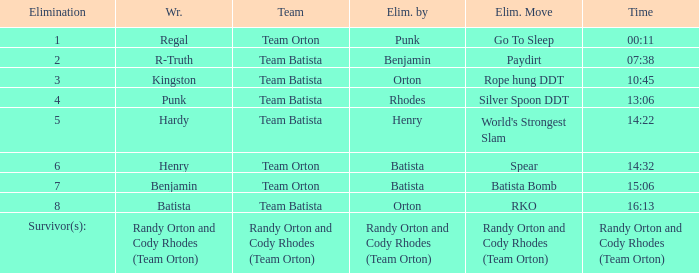Which elimination technique is mentioned at elimination 8 for team batista? RKO. 